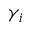<formula> <loc_0><loc_0><loc_500><loc_500>\gamma _ { i }</formula> 